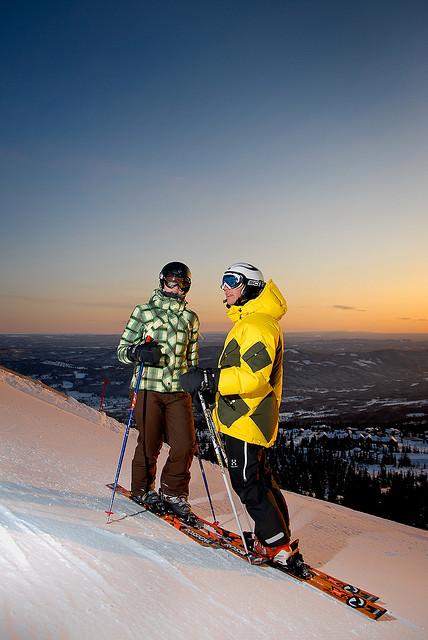Are they wearing helmets?
Keep it brief. Yes. How many skiers?
Short answer required. 2. What shape are the black pattern on the yellow jacket?
Answer briefly. Diamond. 